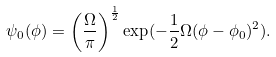Convert formula to latex. <formula><loc_0><loc_0><loc_500><loc_500>\psi _ { 0 } ( \phi ) = \left ( \frac { \Omega } { \pi } \right ) ^ { \frac { 1 } { 2 } } \exp ( - \frac { 1 } { 2 } \Omega ( \phi - \phi _ { 0 } ) ^ { 2 } ) .</formula> 